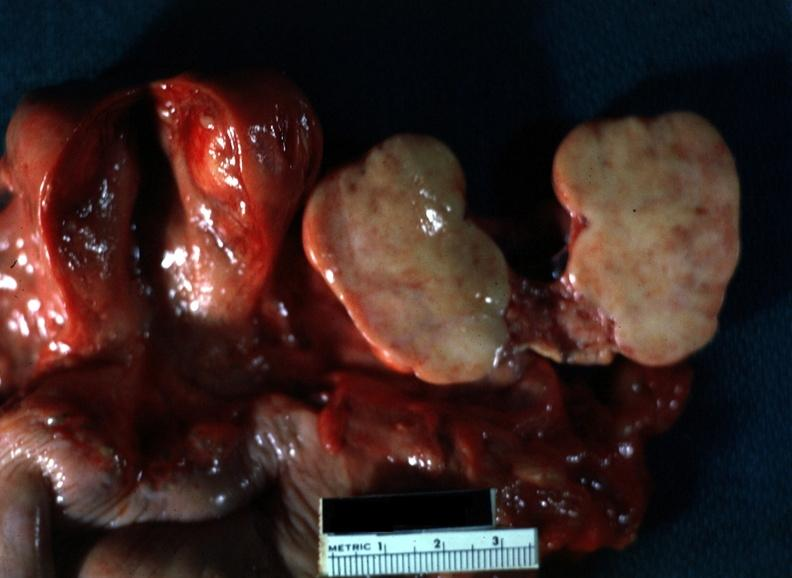s chest and abdomen slide present?
Answer the question using a single word or phrase. No 